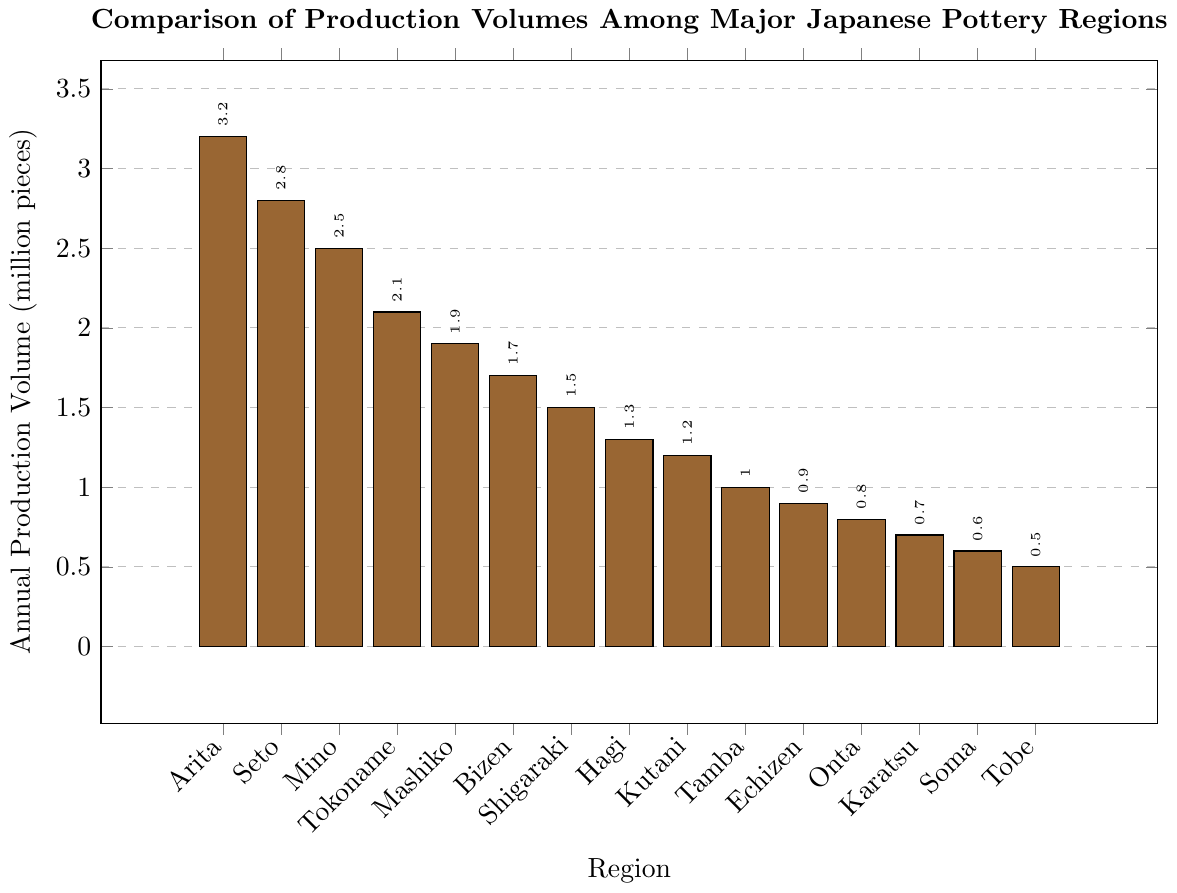How many regions produce more than 2 million pieces annually? Look at the bars for regions with production volumes greater than 2 million pieces. The regions are Arita, Seto, and Mino, which makes a total of 3 regions.
Answer: 3 What is the combined production volume of Bizen, Shigaraki, and Hagi? Add the production volumes of Bizen (1.7), Shigaraki (1.5), and Hagi (1.3). The total is 1.7 + 1.5 + 1.3 = 4.5 million pieces.
Answer: 4.5 Which region produces the least amount of pottery annually and what is the volume? Identify the smallest bar which represents Soma, with a production volume of 0.5 million pieces.
Answer: Soma, 0.5 Compare the production volumes of Tokoname and Mashiko. Which one is higher and by how much? Tokoname produces 2.1 million pieces and Mashiko produces 1.9 million pieces. Subtract Mashiko's volume from Tokoname's to get 2.1 - 1.9 = 0.2 million pieces. So, Tokoname produces 0.2 million pieces more than Mashiko.
Answer: Tokoname, 0.2 What is the average production volume of all regions? Sum up all the production volumes: 3.2 + 2.8 + 2.5 + 2.1 + 1.9 + 1.7 + 1.5 + 1.3 + 1.2 + 1.0 + 0.9 + 0.8 + 0.7 + 0.6 + 0.5 = 22.7. There are 15 regions, so the average is 22.7 / 15 = 1.51 million pieces.
Answer: 1.51 If the production volumes of Echizen and Onta were combined, would they exceed the production volume of Kutani? Sum the production volumes of Echizen (0.9) and Onta (0.8). The total is 0.9 + 0.8 = 1.7. Since Kutani's volume is 1.2 million pieces, the combined volume of Echizen and Onta exceeds Kutani's by 1.7 - 1.2 = 0.5 million pieces.
Answer: Yes, 0.5 Which regions have an annual production volume exactly 1 million pieces or less? Identify the regions with bars for production volumes of 1 million or less: Tamba (1.0), Echizen (0.9), Onta (0.8), Karatsu (0.7), Soma (0.6), and Tobe (0.5).
Answer: Tamba, Echizen, Onta, Karatsu, Soma, Tobe How many more pieces does Arita produce compared to Mashiko? Subtract Mashiko's production volume from Arita's: 3.2 - 1.9 = 1.3 million pieces.
Answer: 1.3 What is the production volume difference between the highest and lowest producing regions? Subtract the production volume of the lowest region (Tobe with 0.5) from the highest (Arita with 3.2): 3.2 - 0.5 = 2.7 million pieces.
Answer: 2.7 